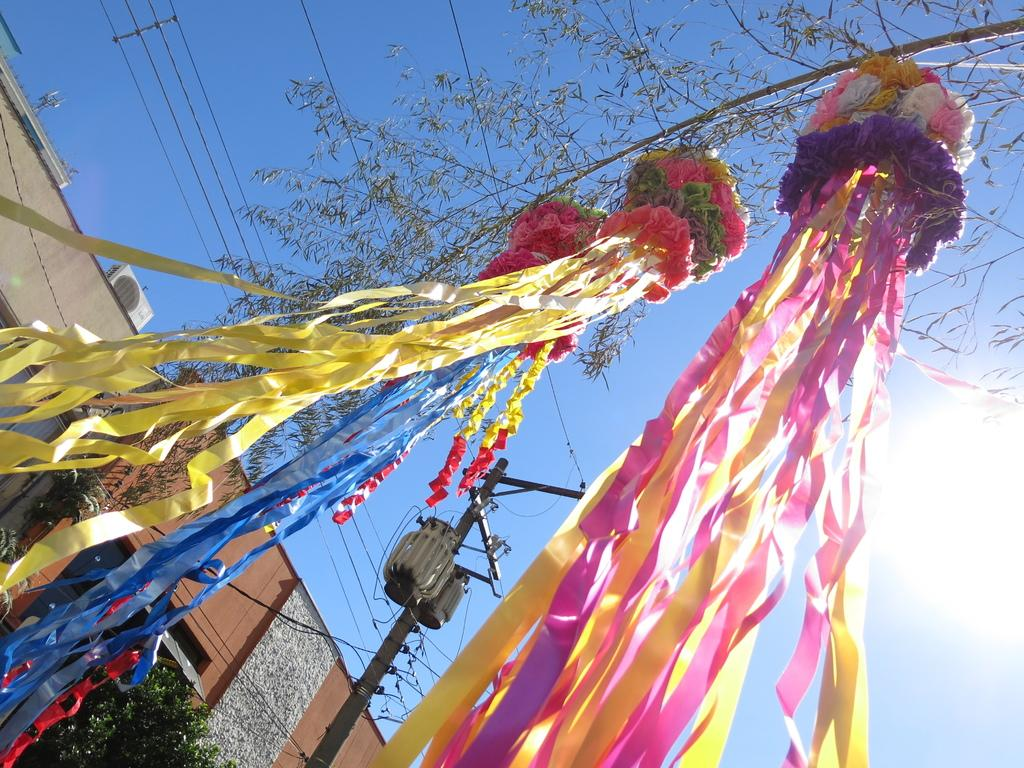What is hanging from the tree in the image? There are paper decoration items tied to a tree in the image. What can be seen on the left side of the image? There are houses on the left side of the image. What is visible at the top of the image? The sky is visible at the top of the image. Where are the scissors located in the image? There are no scissors present in the image. Can you describe the garden in the image? There is no garden present in the image. 